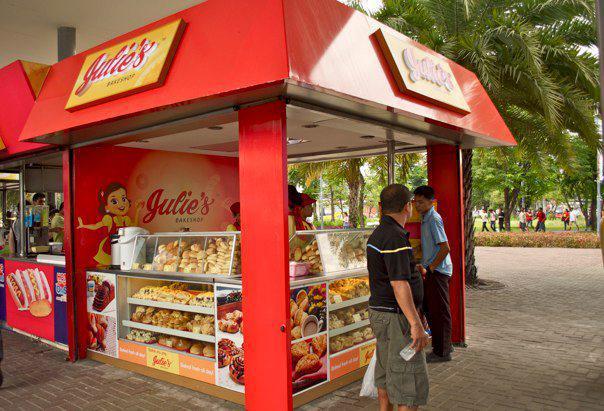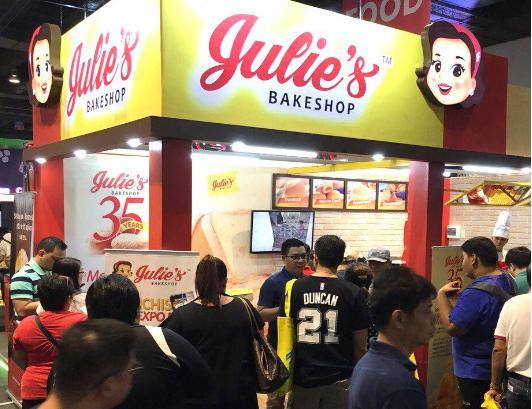The first image is the image on the left, the second image is the image on the right. Considering the images on both sides, is "These stores feature different names in each image of the set." valid? Answer yes or no. No. 